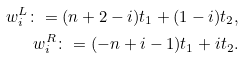Convert formula to latex. <formula><loc_0><loc_0><loc_500><loc_500>w ^ { L } _ { i } \colon = ( n + 2 - i ) t _ { 1 } + ( 1 - i ) t _ { 2 } , \\ w ^ { R } _ { i } \colon = ( - n + i - 1 ) t _ { 1 } + i t _ { 2 } .</formula> 